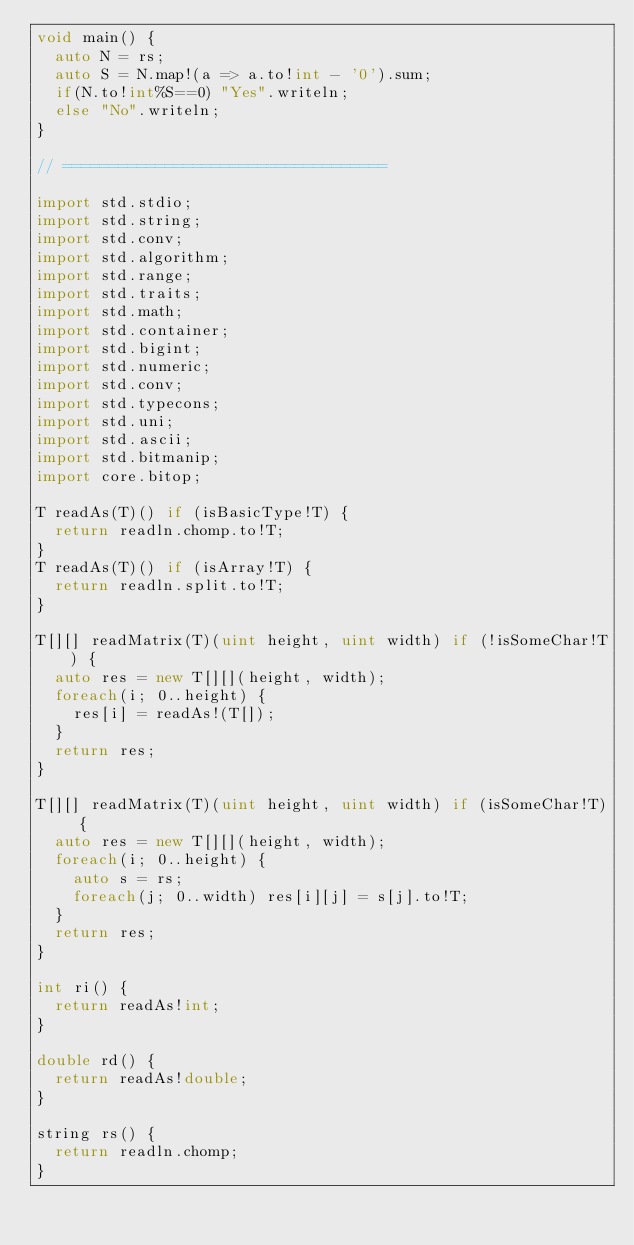<code> <loc_0><loc_0><loc_500><loc_500><_D_>void main() {
	auto N = rs;
	auto S = N.map!(a => a.to!int - '0').sum;
	if(N.to!int%S==0) "Yes".writeln;
	else "No".writeln;
}

// ===================================

import std.stdio;
import std.string;
import std.conv;
import std.algorithm;
import std.range;
import std.traits;
import std.math;
import std.container;
import std.bigint;
import std.numeric;
import std.conv;
import std.typecons;
import std.uni;
import std.ascii;
import std.bitmanip;
import core.bitop;

T readAs(T)() if (isBasicType!T) {
	return readln.chomp.to!T;
}
T readAs(T)() if (isArray!T) {
	return readln.split.to!T;
}

T[][] readMatrix(T)(uint height, uint width) if (!isSomeChar!T) {
	auto res = new T[][](height, width);
	foreach(i; 0..height) {
		res[i] = readAs!(T[]);
	}
	return res;
}

T[][] readMatrix(T)(uint height, uint width) if (isSomeChar!T) {
	auto res = new T[][](height, width);
	foreach(i; 0..height) {
		auto s = rs;
		foreach(j; 0..width) res[i][j] = s[j].to!T;
	}
	return res;
}

int ri() {
	return readAs!int;
}

double rd() {
	return readAs!double;
}

string rs() {
	return readln.chomp;
}
</code> 